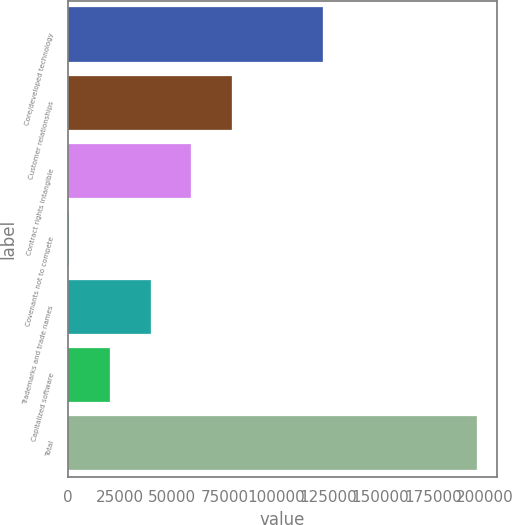<chart> <loc_0><loc_0><loc_500><loc_500><bar_chart><fcel>Core/developed technology<fcel>Customer relationships<fcel>Contract rights intangible<fcel>Covenants not to compete<fcel>Trademarks and trade names<fcel>Capitalized software<fcel>Total<nl><fcel>122537<fcel>78667.4<fcel>59106.8<fcel>425<fcel>39546.2<fcel>19985.6<fcel>196031<nl></chart> 